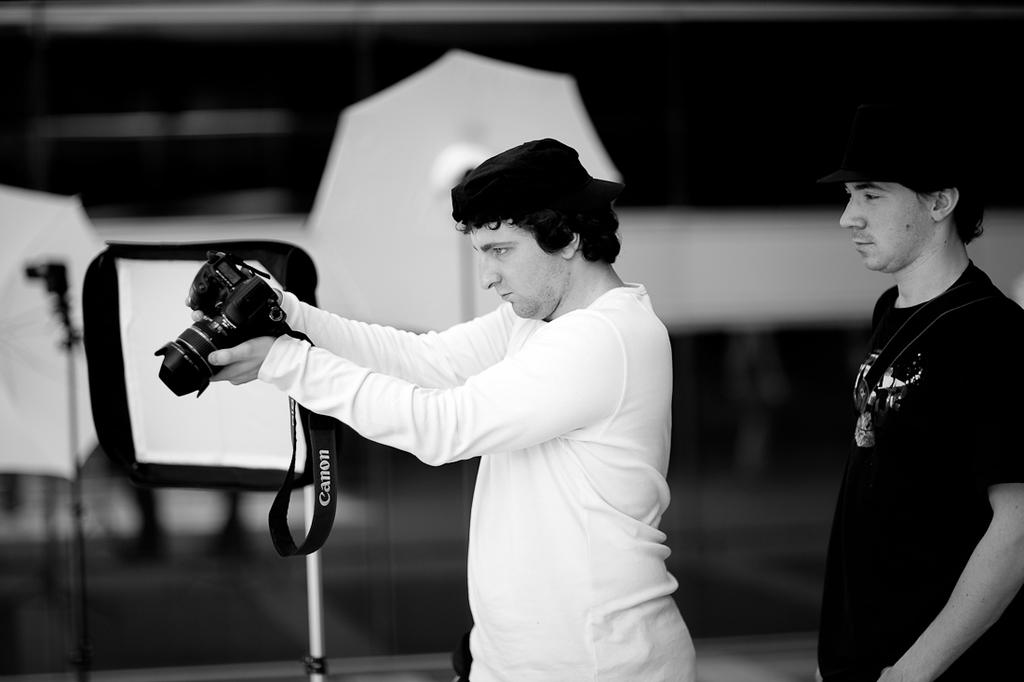What is the color scheme of the image? The image is black and white. How many people are in the image? There are two persons standing in the image. What is one person doing in the image? One person is holding a camera. What can be seen in the distance in the image? There are umbrellas visible in the distance. Where is the grandmother standing with her pet deer in the image? There is no grandmother or pet deer present in the image. What type of cheese is being offered to the person holding the camera in the image? There is no cheese present in the image. 